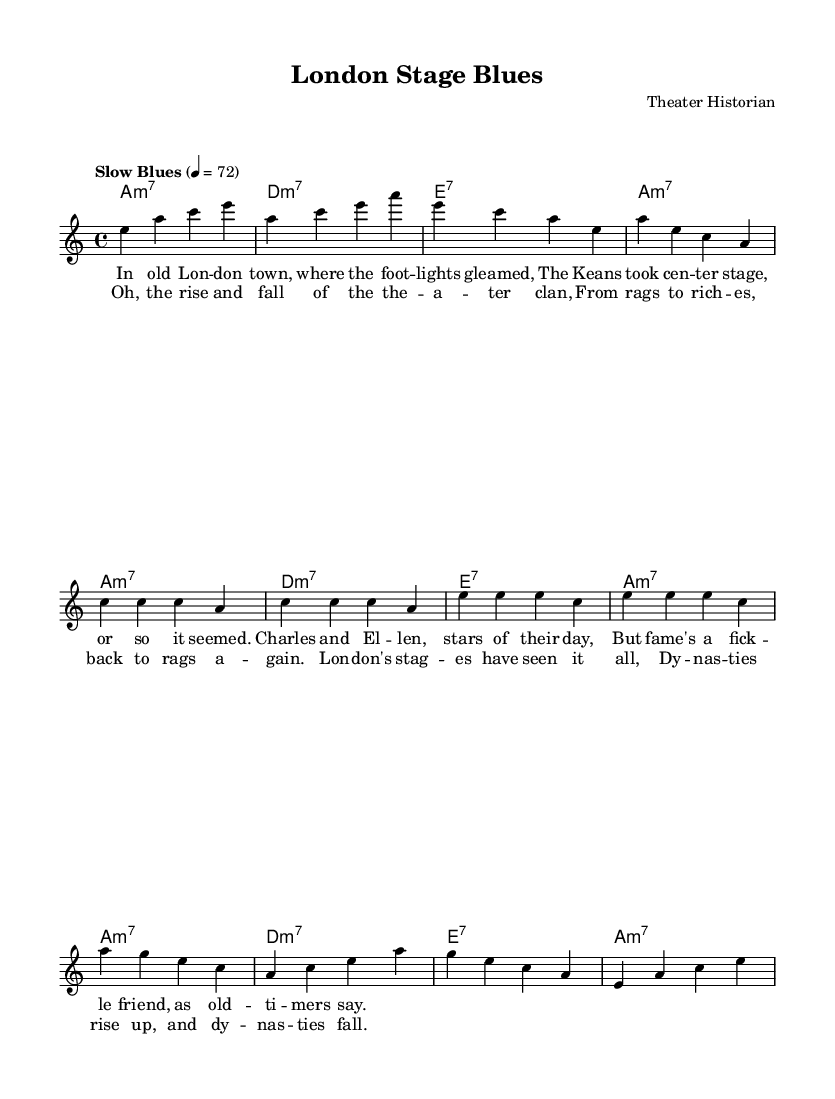what is the key signature of this music? The key signature is A minor, which has no sharps or flats.
Answer: A minor what is the time signature of this music? The time signature is 4/4, indicating four beats per measure.
Answer: 4/4 what is the tempo marking of the piece? The tempo marking is "Slow Blues," which indicates a relaxed pace typical of the blues genre.
Answer: Slow Blues how many measures are in the verse section? The verse consists of eight measures, as indicated by the segments in the melody.
Answer: Eight what chord is played at the beginning of the first verse? The chord played at the beginning of the first verse is A minor seventh, as seen in the harmonic structure.
Answer: A minor seventh how does the chorus differ from the verse in terms of melody range? The chorus melody primarily uses higher notes compared to the verse, showcasing a rise in pitch.
Answer: Higher notes what blues characteristic is present in this music? A characteristic of blues present in this piece is the use of call and response, particularly in the lyrical structure.
Answer: Call and response 